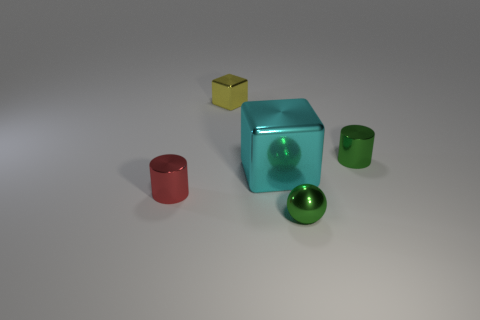There is a block that is in front of the object to the right of the tiny green sphere; how big is it?
Provide a short and direct response. Large. The green metal ball is what size?
Provide a succinct answer. Small. Does the tiny cylinder that is behind the cyan metal block have the same color as the shiny cylinder in front of the green shiny cylinder?
Your answer should be very brief. No. What number of other objects are the same material as the small sphere?
Provide a short and direct response. 4. Are there any red objects?
Your answer should be compact. Yes. Are the small green object in front of the red thing and the big block made of the same material?
Ensure brevity in your answer.  Yes. There is another object that is the same shape as the yellow object; what is it made of?
Offer a very short reply. Metal. There is a object that is the same color as the small shiny ball; what is its material?
Your answer should be very brief. Metal. Are there fewer cyan metal things than green shiny things?
Make the answer very short. Yes. Does the small cylinder that is behind the red cylinder have the same color as the large metallic cube?
Offer a very short reply. No. 